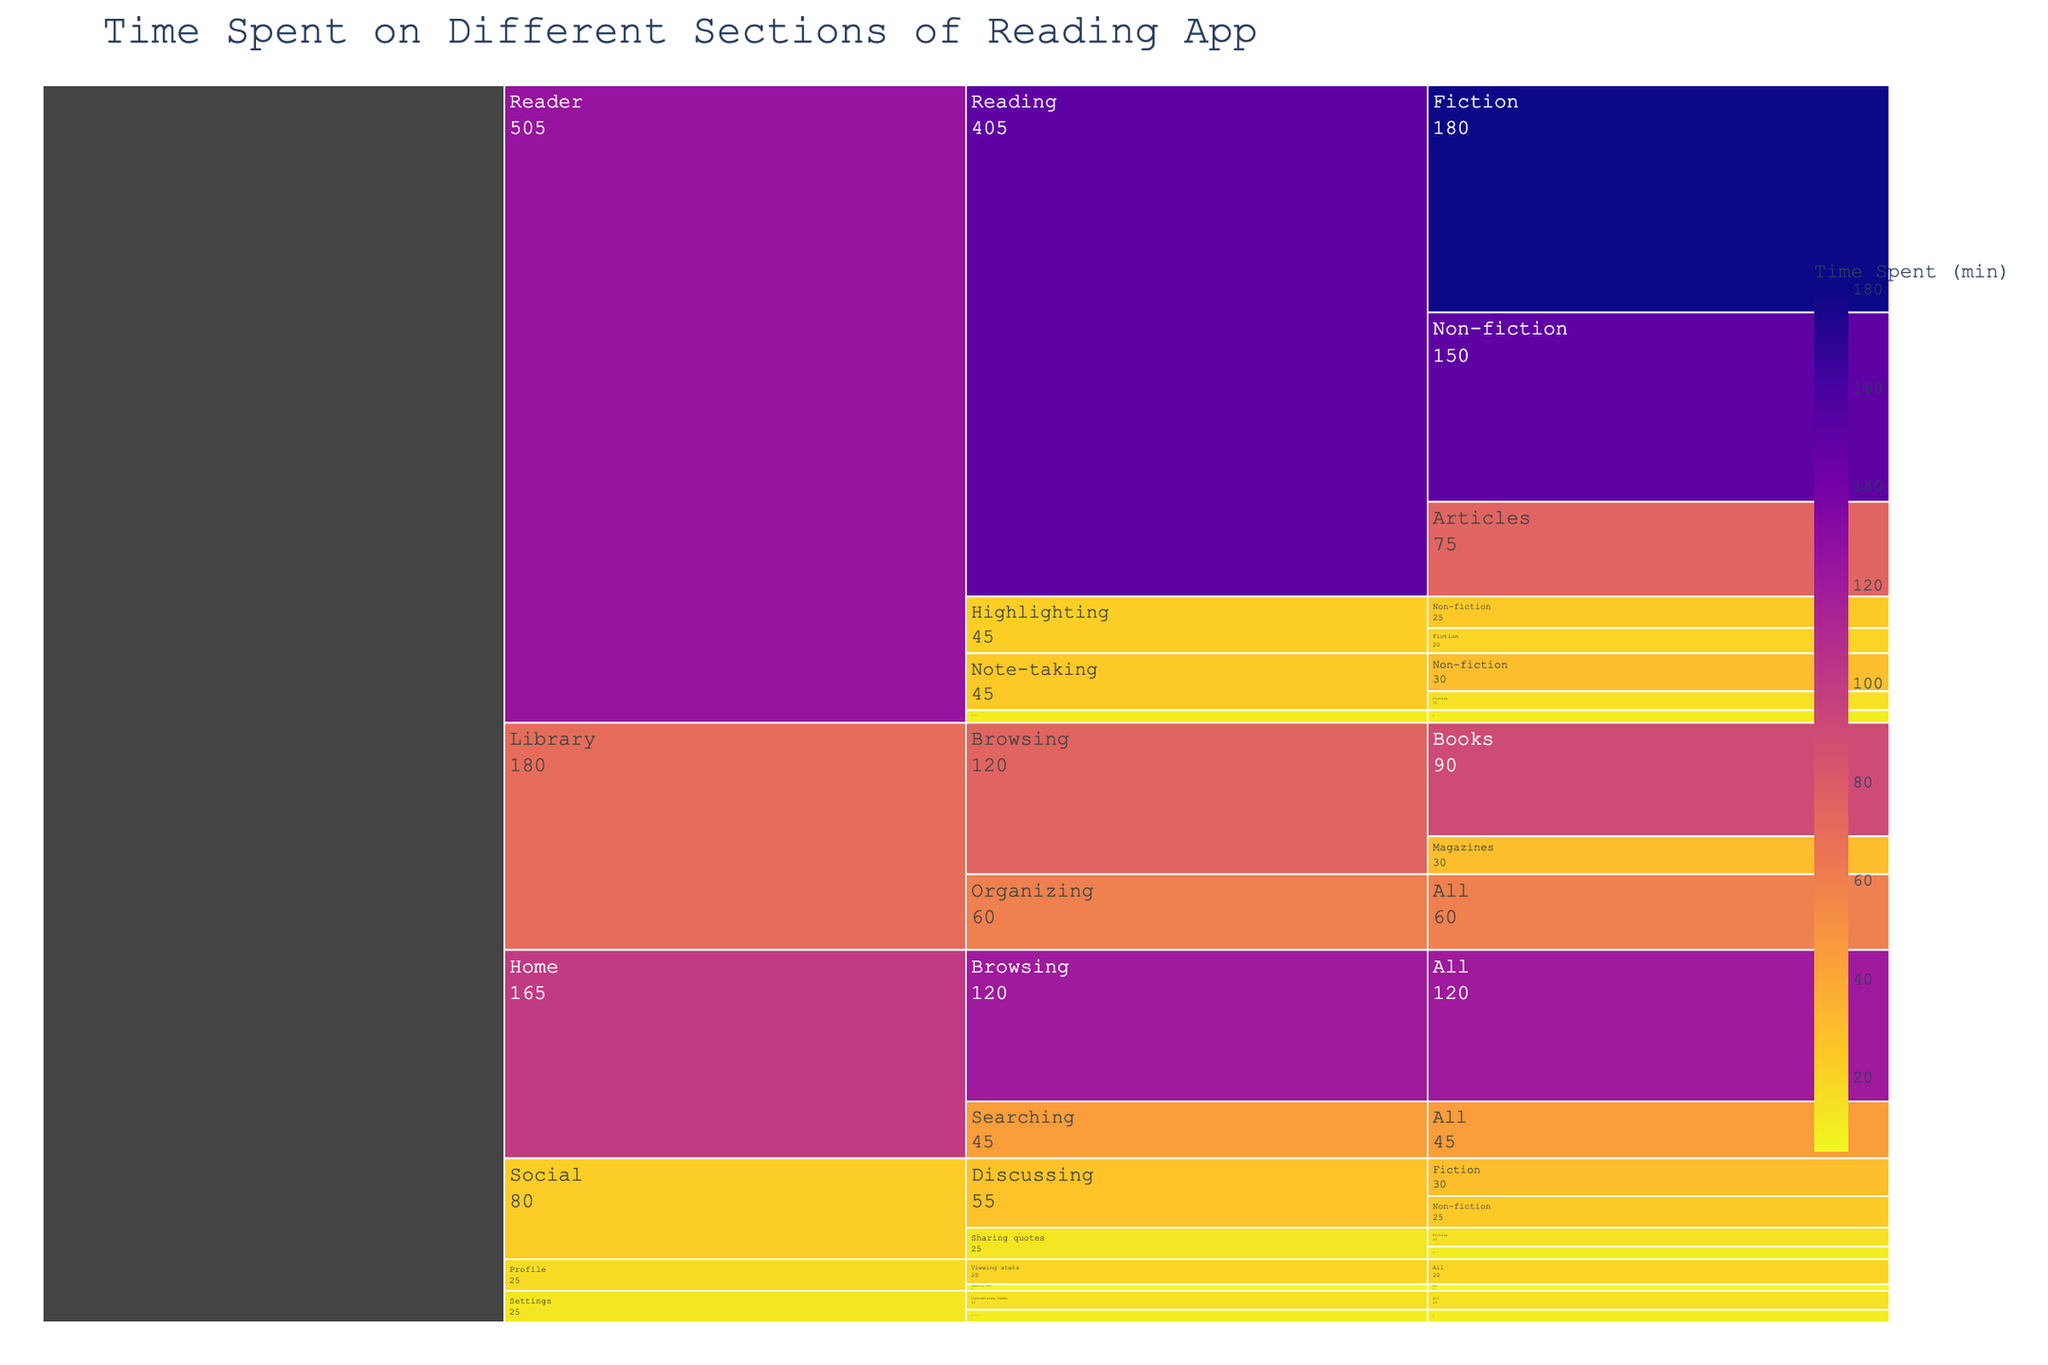what is the total time spent in the "Home" section? Locate the "Home" section in the chart and sum up the time spent on different activities within this section — 120 minutes for Browsing and 45 minutes for Searching, resulting in 165 minutes total.
Answer: 165 Which section has the highest total time spent? Compare the total times for each section. The "Reader" section has the highest time spent, with multiple activities accumulating to more than other sections.
Answer: Reader How much time is spent on "Highlighting" activities in the "Reader" section? Within the "Reader" section, sum the time spent on highlighting activities. Highlighting Fiction takes 20 minutes and Non-fiction takes 25 minutes, totaling 45 minutes.
Answer: 45 In "Social" activities, is more time spent on "Sharing quotes" or "Discussing"? Compare the times for "Sharing quotes" and "Discussing" in the "Social" section. Sharing quotes totals 25 minutes (15 for Fiction and 10 for Non-fiction), whereas Discussing totals 55 minutes (30 for Fiction and 25 for Non-fiction).
Answer: Discussing Which content type has the least time spent in the "Reader" section? Within the "Reader" section, compare the content types. "Articles" have the least time spent, with 75 minutes.
Answer: Articles what is the average time spent on "Note-taking" activities in the "Reader" section? Calculate the average time for note-taking activities within the "Reader" section. Note-taking Fiction is 15 minutes, and Non-fiction is 30 minutes, thus the average is (15+30)/2 = 22.5 minutes.
Answer: 22.5 How much more time is spent on "Organizing" activities in the "Library" section than on "Customizing theme" in the "Settings" section? Subtract the time for "Customizing theme" (15 minutes) from the time for "Organizing" (60 minutes). This results in a difference of 45 minutes.
Answer: 45 In the "Library" section, which content type has more time spent on "Browsing" activities: "Books" or "Magazines"? Compare the time spent on browsing Books (90 minutes) and Magazines (30 minutes) within the Library section.
Answer: Books Which section has the least total time spent across all activities? Check the sum of time spent in all activities for each section and identify the section with the least sum. The "Profile" section has the least total time with 25 minutes (5 for Updating info and 20 for Viewing stats).
Answer: Profile How does the time spent on "Adjusting font" in the "Settings" section compare to the time spent "Updating info" in the "Profile" section? Compare the two times directly: 10 minutes for "Adjusting font" and 5 minutes for "Updating info".
Answer: Adjusting font has more time 